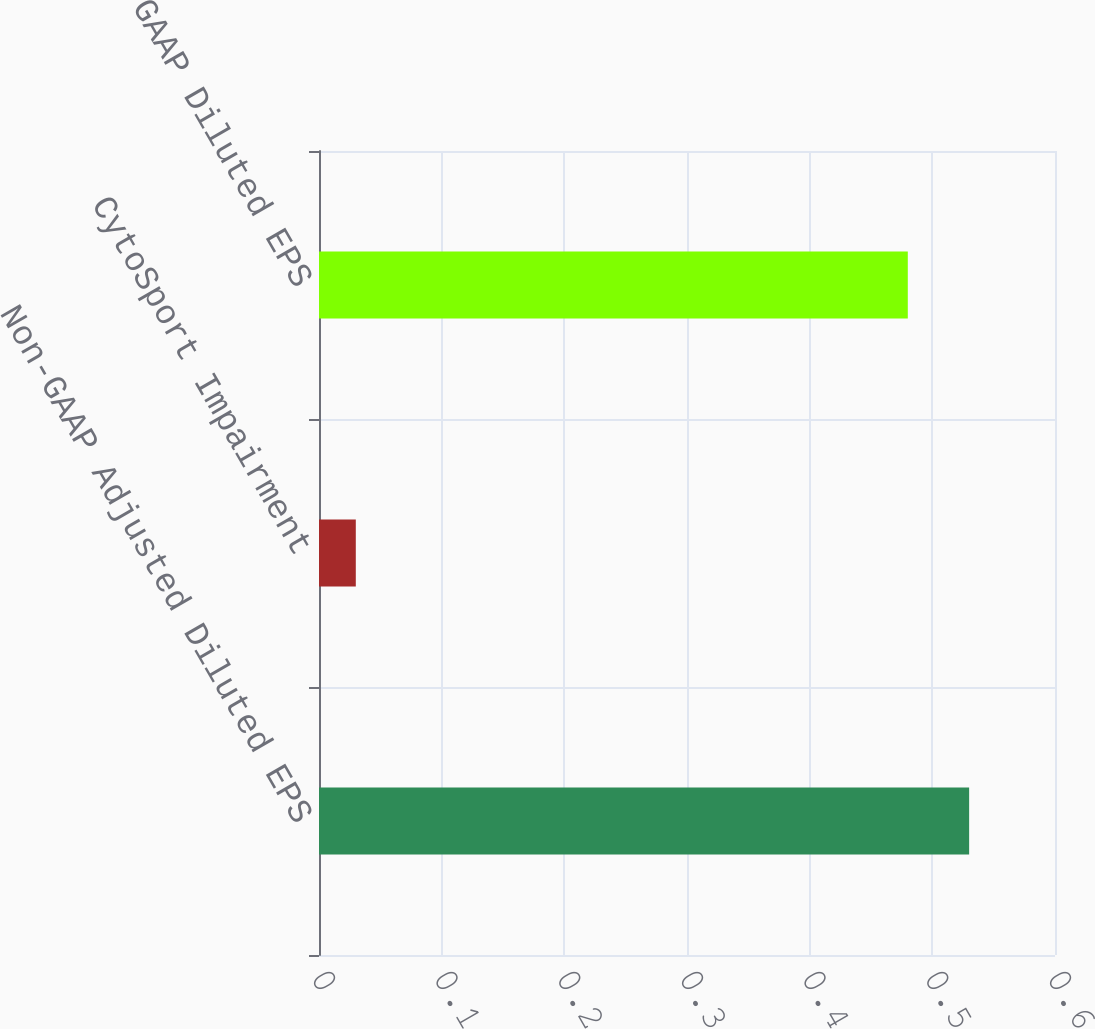Convert chart to OTSL. <chart><loc_0><loc_0><loc_500><loc_500><bar_chart><fcel>Non-GAAP Adjusted Diluted EPS<fcel>CytoSport Impairment<fcel>GAAP Diluted EPS<nl><fcel>0.53<fcel>0.03<fcel>0.48<nl></chart> 